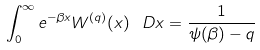<formula> <loc_0><loc_0><loc_500><loc_500>\int _ { 0 } ^ { \infty } e ^ { - \beta x } W ^ { ( q ) } ( x ) \, \ D x = \frac { 1 } { \psi ( \beta ) - q }</formula> 